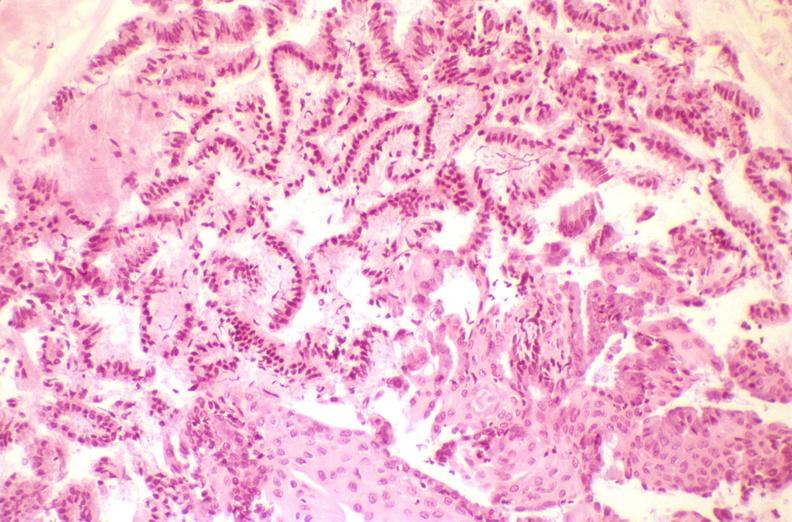what does this image show?
Answer the question using a single word or phrase. Cervix 